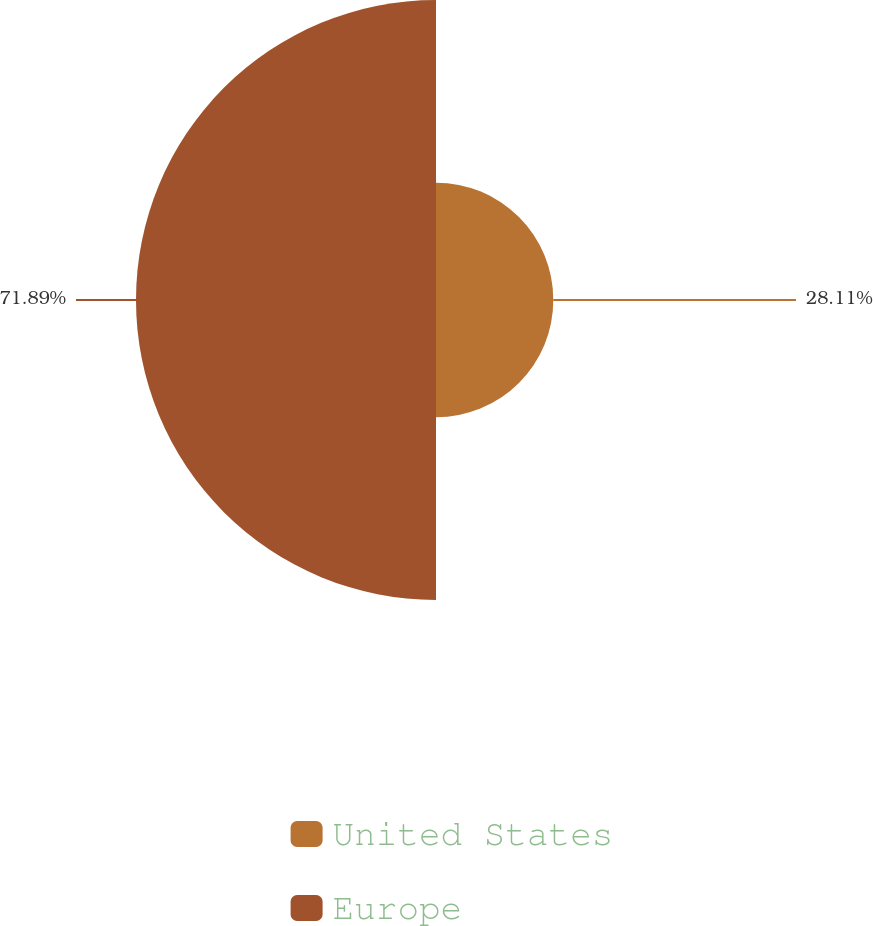Convert chart. <chart><loc_0><loc_0><loc_500><loc_500><pie_chart><fcel>United States<fcel>Europe<nl><fcel>28.11%<fcel>71.89%<nl></chart> 